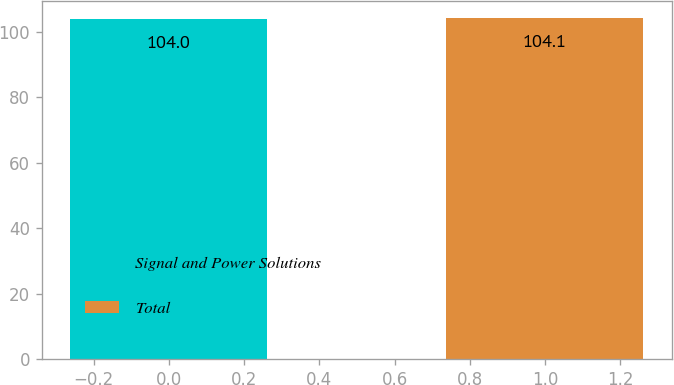Convert chart to OTSL. <chart><loc_0><loc_0><loc_500><loc_500><bar_chart><fcel>Signal and Power Solutions<fcel>Total<nl><fcel>104<fcel>104.1<nl></chart> 